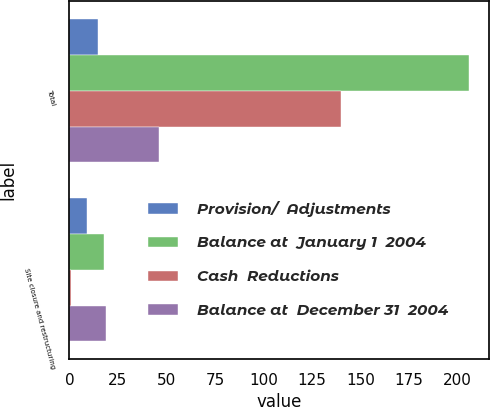<chart> <loc_0><loc_0><loc_500><loc_500><stacked_bar_chart><ecel><fcel>Total<fcel>Site closure and restructuring<nl><fcel>Provision/  Adjustments<fcel>15<fcel>9<nl><fcel>Balance at  January 1  2004<fcel>206<fcel>18<nl><fcel>Cash  Reductions<fcel>140<fcel>1<nl><fcel>Balance at  December 31  2004<fcel>46<fcel>19<nl></chart> 